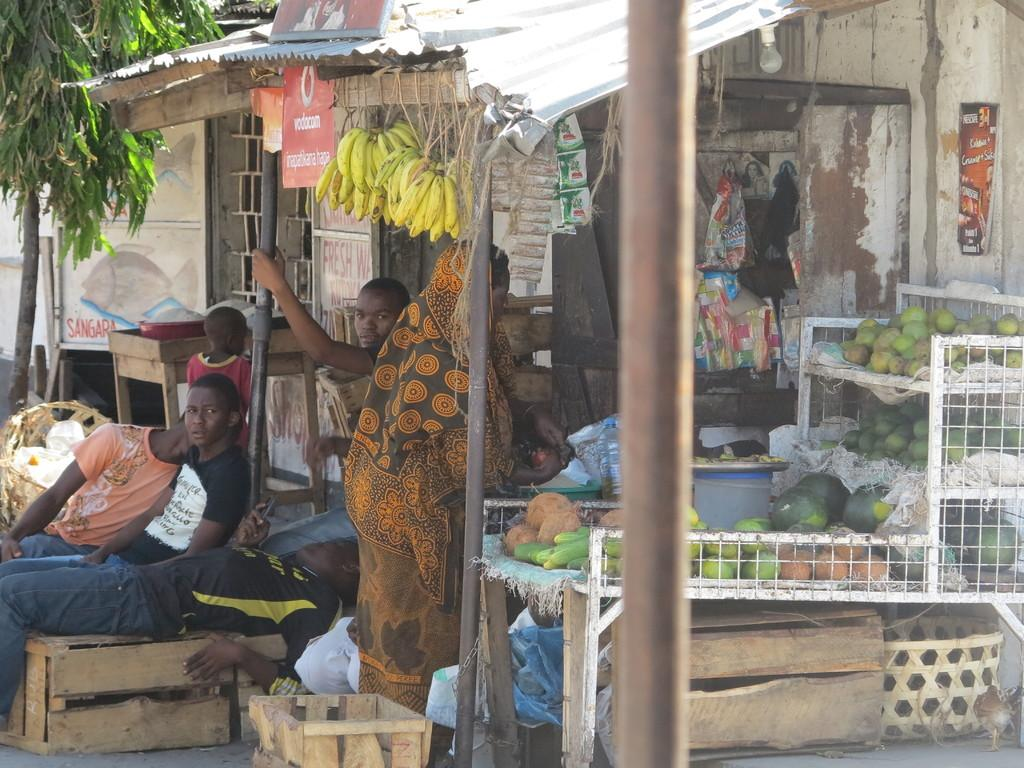What type of establishment is depicted in the image? There is a shop in the image. Are there any people inside the shop? Yes, there are persons in the shop. What items can be seen in the shop? There are boxes, fruits, and packets in the shop. Is there any vegetation visible near the shop? Yes, there is a tree beside the shop. How many cents are visible on the floor in the image? There are no cents visible on the floor in the image. Can you tell me how many times the person in the shop sneezed? There is no information about anyone sneezing in the image. 